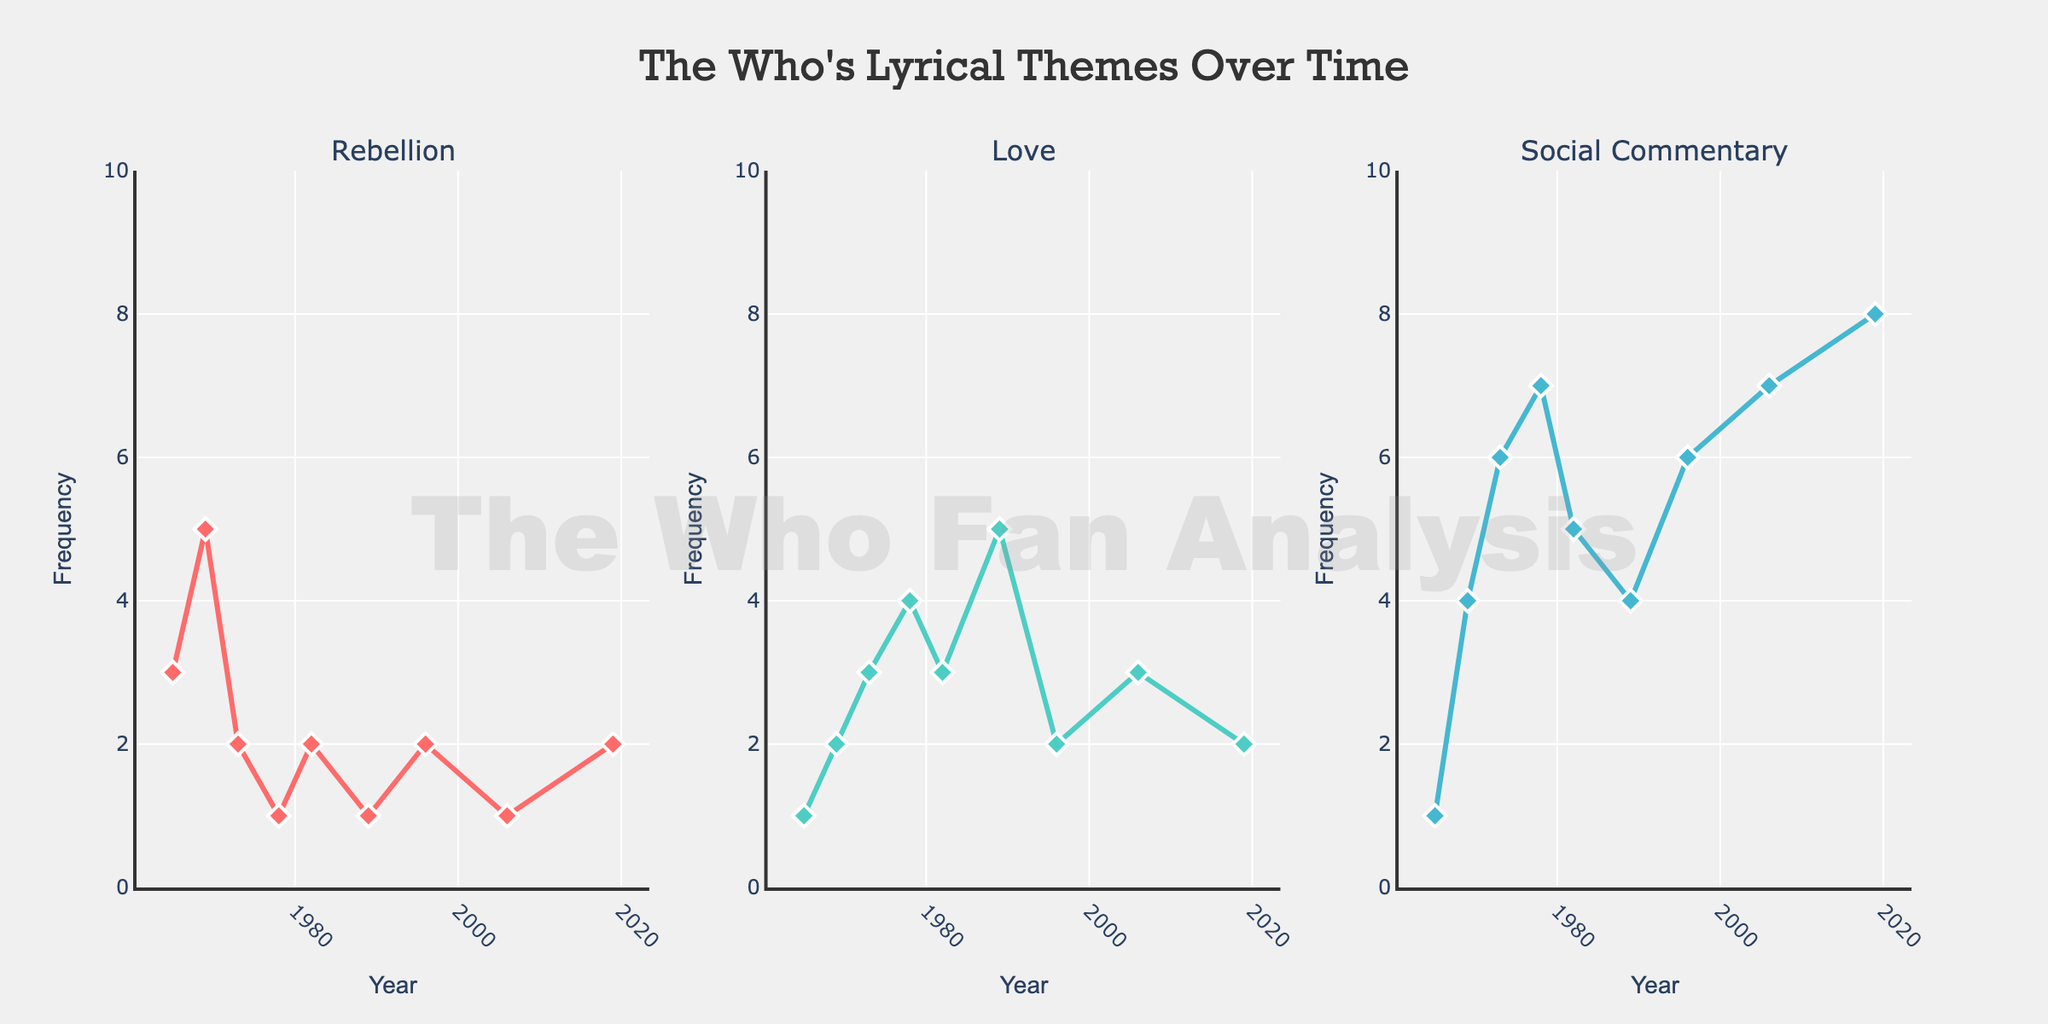What's the title of the figure? The title of the figure is prominently displayed at the top of the chart in a larger font. It reads "The Who's Lyrical Themes Over Time".
Answer: The Who's Lyrical Themes Over Time Which theme shows the highest frequency in 2019? Looking at the subplot for 2019, the theme with the highest dot (most elevated y-value) is "Social Commentary" with a frequency of 8.
Answer: Social Commentary How has the occurrence of the theme of rebellion changed from 1965 to 1982? By examining the points on the Rebellion subplot, the frequency starts at 3 in 1965, increases to 5 in 1969, and then gradually decreases to 2 by 1982.
Answer: Decreased What's the difference in the frequency of the theme of love between 1978 and 1989? For the theme of love, the frequencies are 4 in 1978 and 5 in 1989. Subtracting these gives 5 - 4 = 1.
Answer: 1 In which year does the theme of love reach its peak? Checking the peaks in the Love subplot, the highest frequency is 5, which occurs in 1989.
Answer: 1989 Which year shows the most balanced frequency across all three themes? Observing the figures, the year 1982 has relatively balanced frequencies for Rebellion (2), Love (3), and Social Commentary (5), the smallest range between the maximum and minimum.
Answer: 1982 What is the average frequency of Social Commentary from 1965 to 2019? Summing up the frequencies of Social Commentary for all the years gives 1 + 4 + 6 + 7 + 5 + 4 + 6 + 7 + 8 = 48. Dividing by the number of years (9) results in 48 / 9 ≈ 5.33.
Answer: ~5.33 Which theme shown tends to see a gradual increase over time? The subplot for Social Commentary shows a gradual increase from 1 in 1965 to 8 in 2019.
Answer: Social Commentary In which year does the frequency of rebellion drop to its lowest point? On the Rebellion subplot, the lowest points, equally low, are in the years 1978 and 1989, each showing a frequency of 1.
Answer: 1978 and 1989 How many themes show a peak in frequency in 2006? In 2006, only the theme of Social Commentary reaches its peak frequency of 7.
Answer: 1 